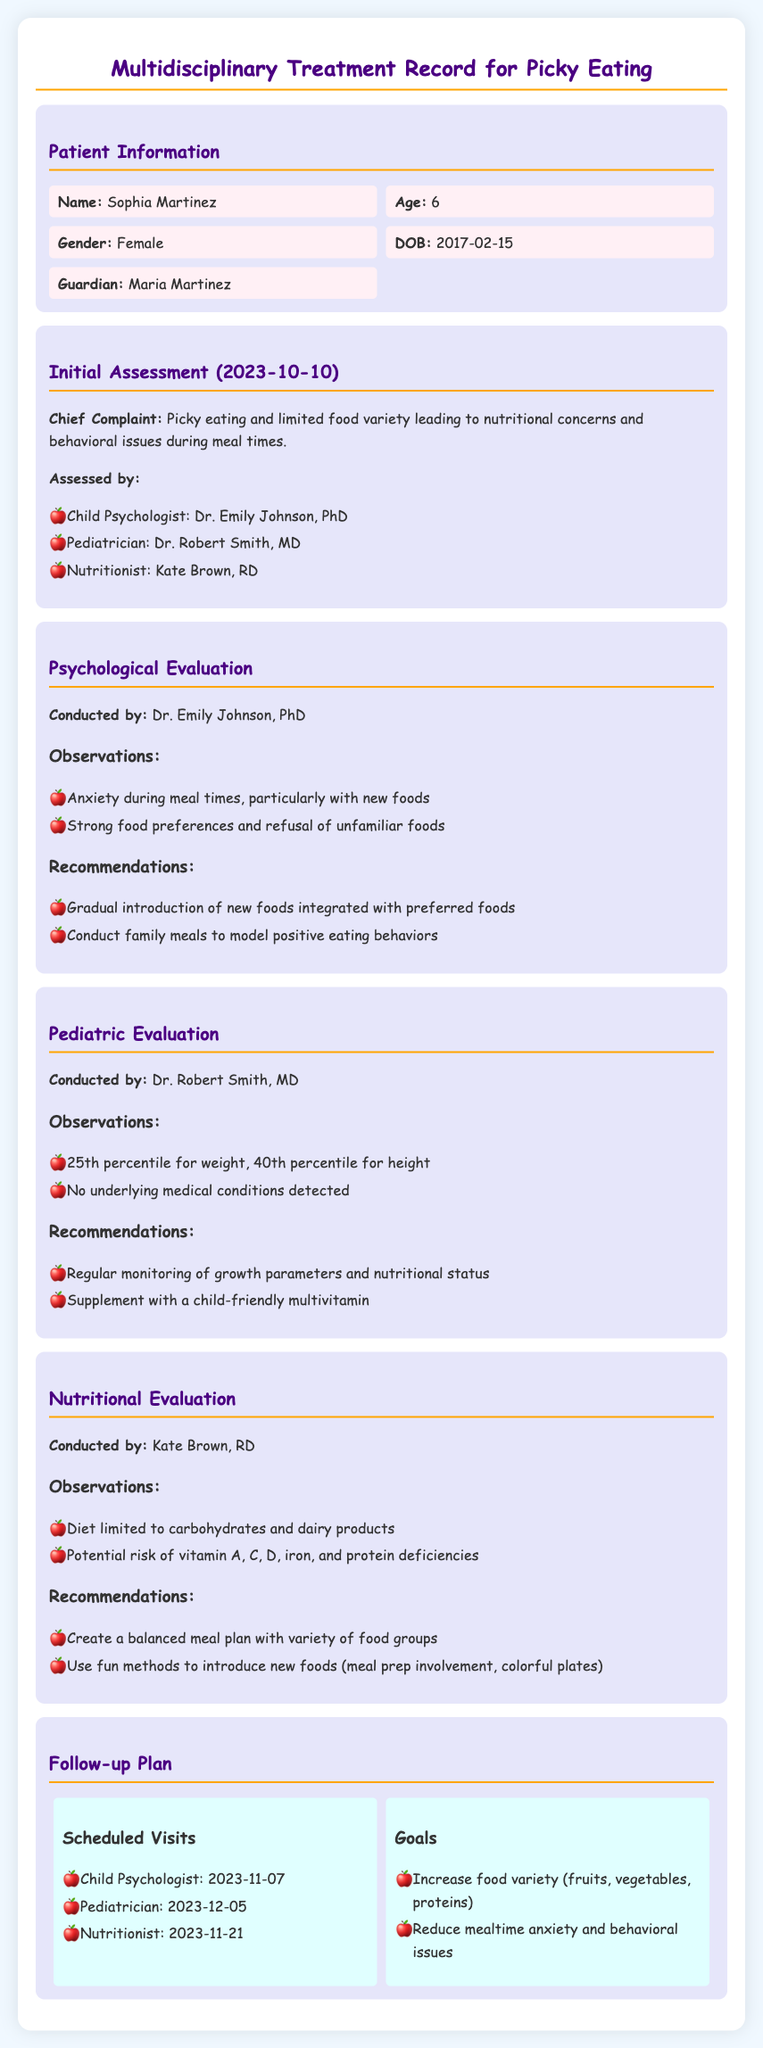What is the name of the patient? The patient's name is listed in the Patient Information section.
Answer: Sophia Martinez Who conducted the psychological evaluation? The document explicitly states the person who conducted the psychological evaluation.
Answer: Dr. Emily Johnson, PhD What is Sophia's age? The age of the patient is mentioned in the Patient Information section.
Answer: 6 What percentile is Sophia for height? The pediatric evaluation provides the details about the patient's growth metrics.
Answer: 40th percentile What is the main concern regarding Sophia's diet? The chief complaint highlights the main issue related to the patient's eating behavior.
Answer: Limited food variety What is the follow-up date for the nutritionist? The follow-up dates are outlined in the Follow-up Plan section.
Answer: 2023-11-21 What is one recommendation from the nutritional evaluation? The recommendations provided in the nutritional evaluation detail strategies to improve Sophia's diet.
Answer: Create a balanced meal plan with variety of food groups What is the goal related to mealtime anxiety? The goals established in the Follow-up Plan provide objective targets for treatment.
Answer: Reduce mealtime anxiety and behavioral issues What type of professionals are involved in Sophia's treatment? The Initial Assessment lists the different professionals contributing to the patient's care.
Answer: Child Psychologist, Pediatrician, Nutritionist 